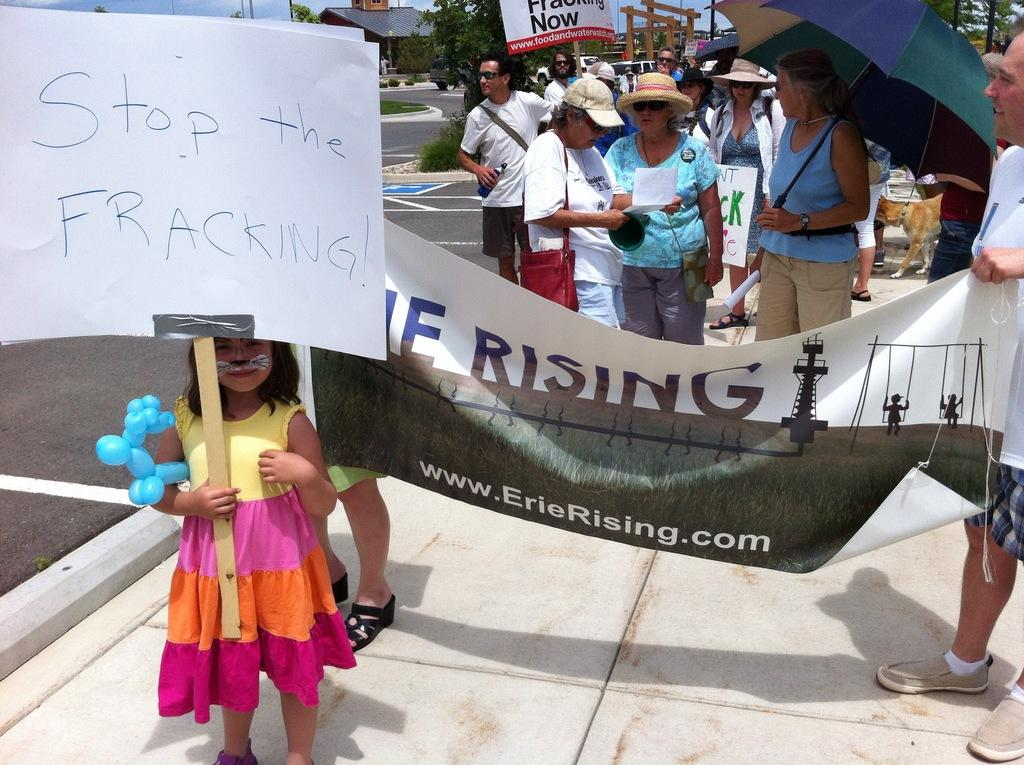What are the people in the image doing? The people in the image are standing and holding banners, umbrellas, and papers. What might the banners, umbrellas, and papers signify? The banners, umbrellas, and papers might signify a protest or gathering. What can be seen in the background of the image? In the background of the image, there are trees, poles, and buildings. How many different items are the people holding in the image? The people are holding three different items: banners, umbrellas, and papers. What type of arithmetic problem can be seen written on the banners in the image? There is no arithmetic problem visible on the banners in the image. 